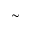Convert formula to latex. <formula><loc_0><loc_0><loc_500><loc_500>\sim</formula> 